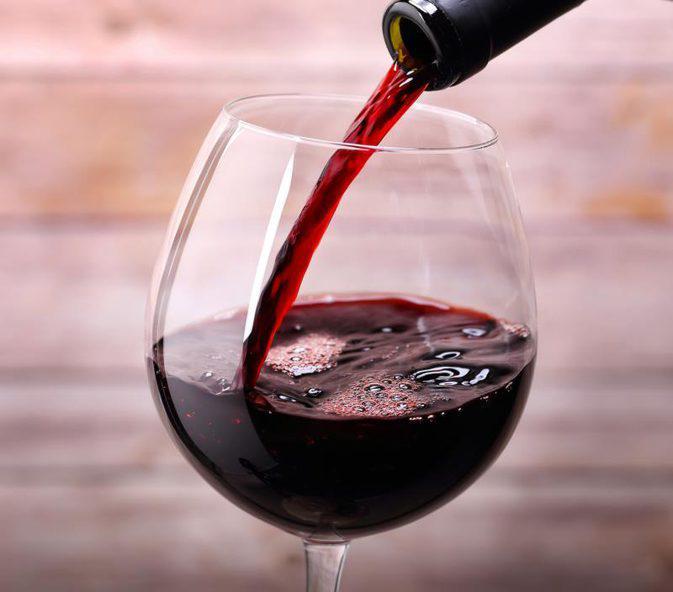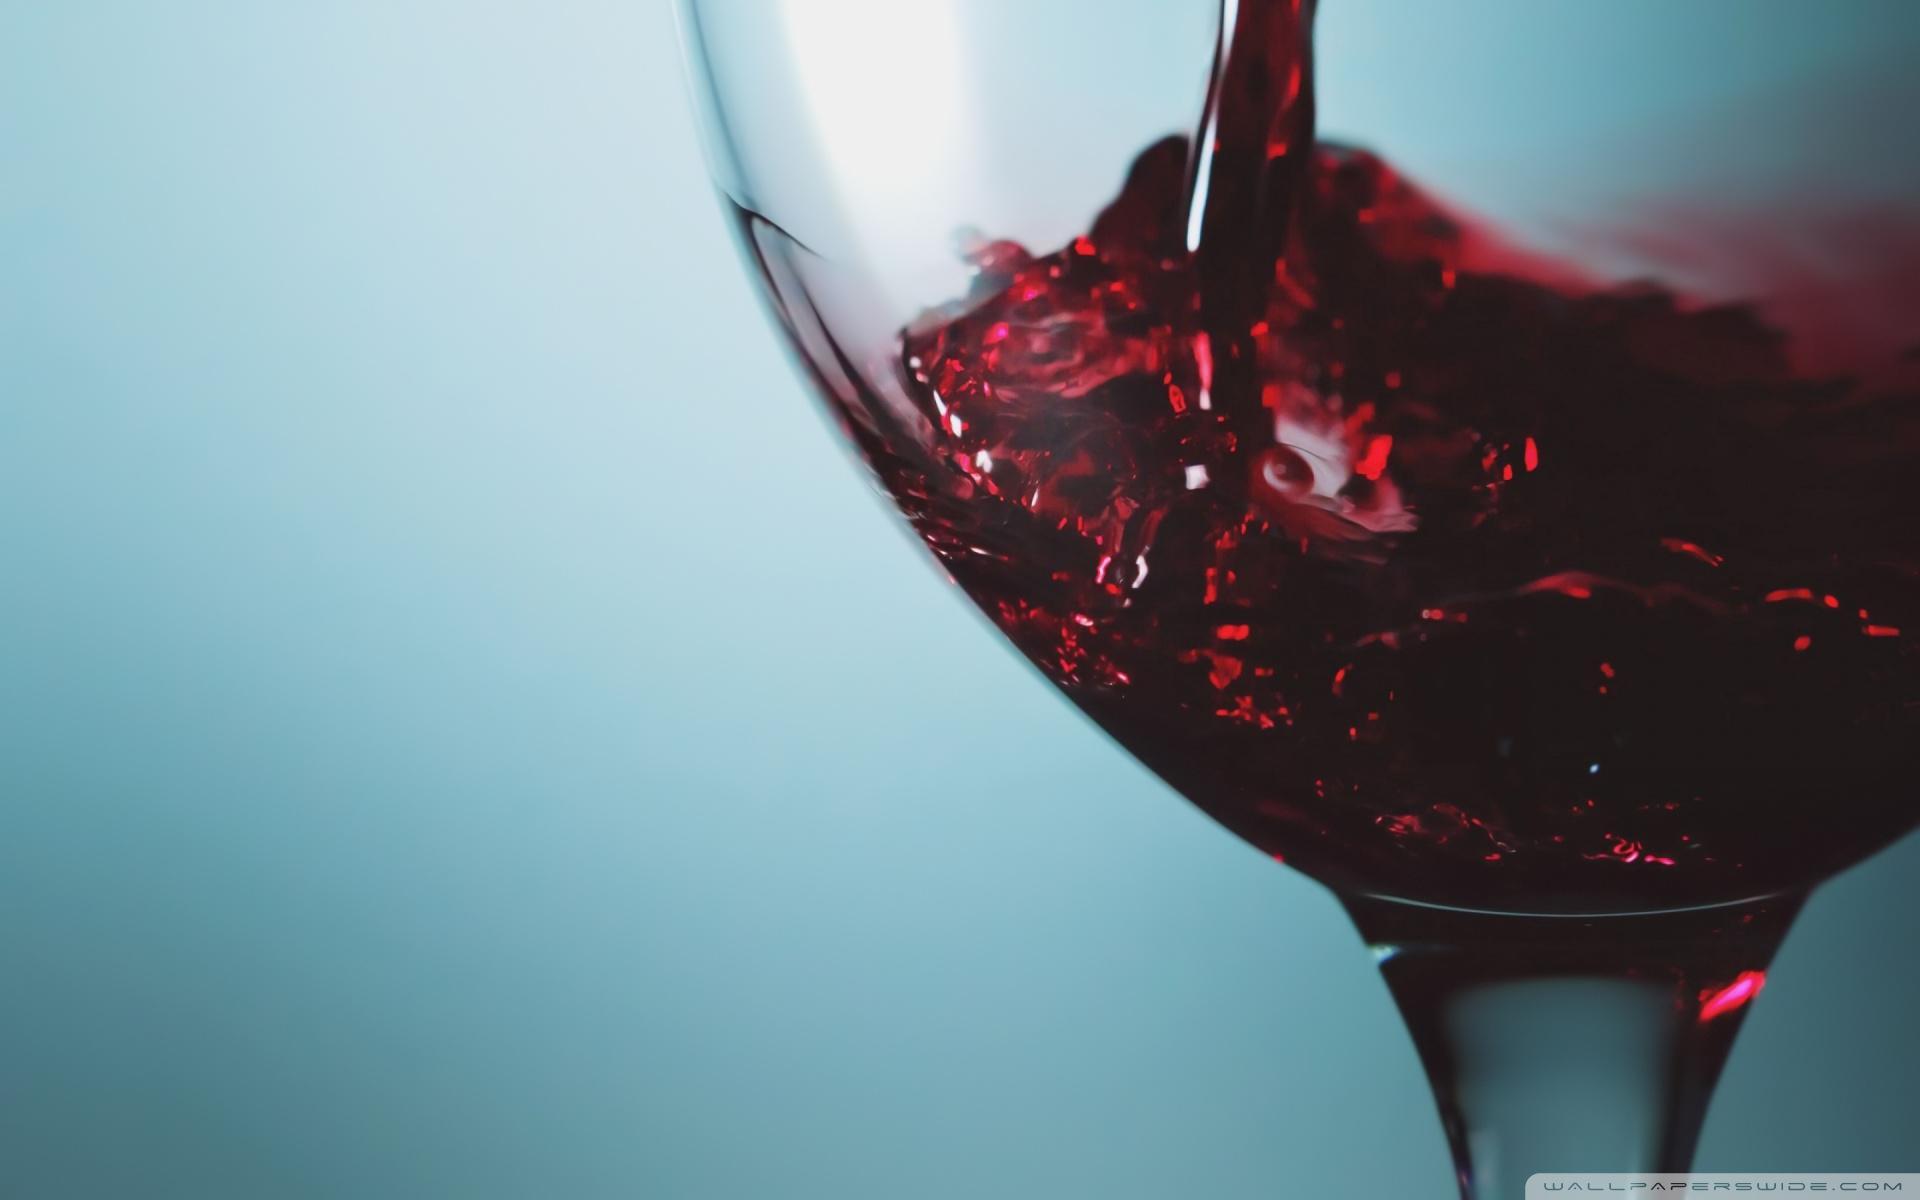The first image is the image on the left, the second image is the image on the right. Evaluate the accuracy of this statement regarding the images: "The left image shows burgundy wine pouring into a glass.". Is it true? Answer yes or no. Yes. 